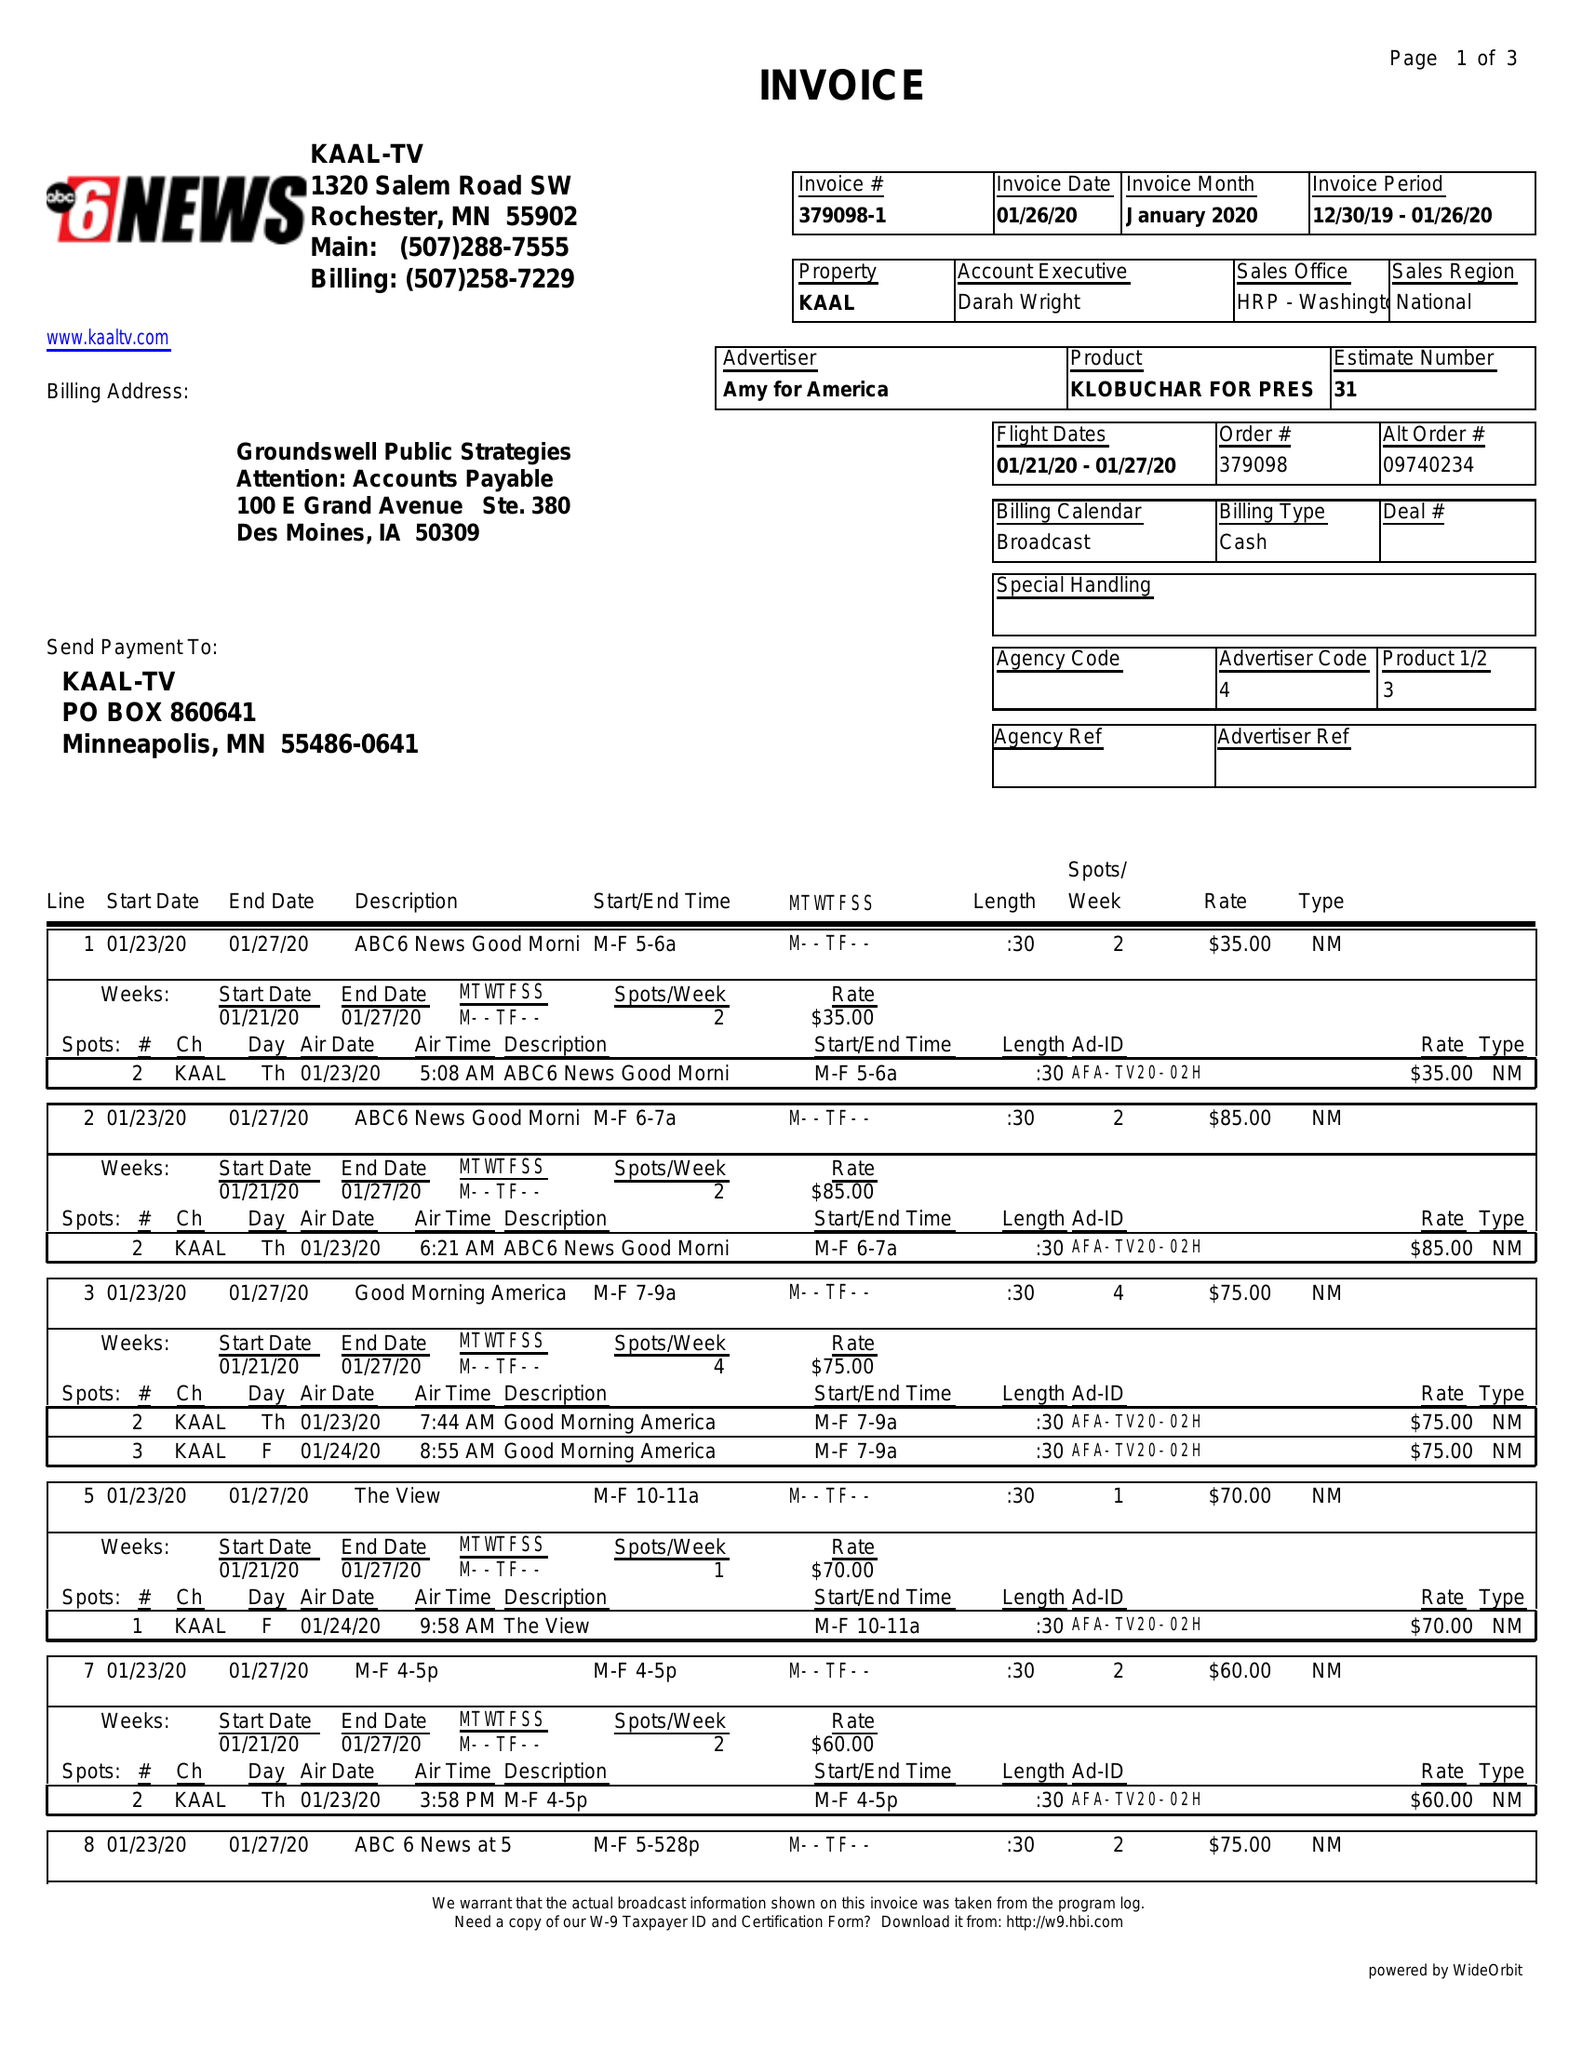What is the value for the gross_amount?
Answer the question using a single word or phrase. 2055.00 